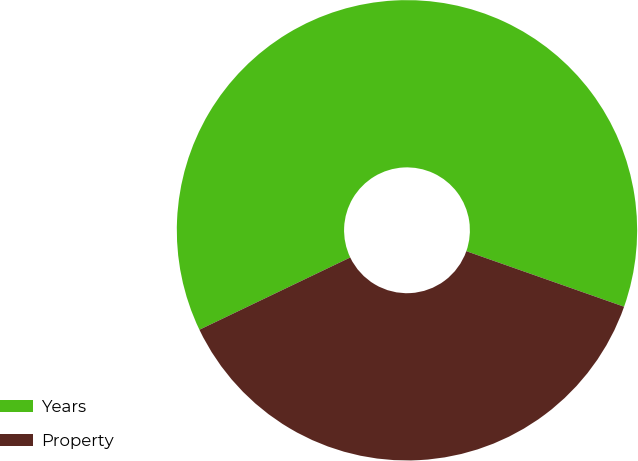<chart> <loc_0><loc_0><loc_500><loc_500><pie_chart><fcel>Years<fcel>Property<nl><fcel>62.5%<fcel>37.5%<nl></chart> 